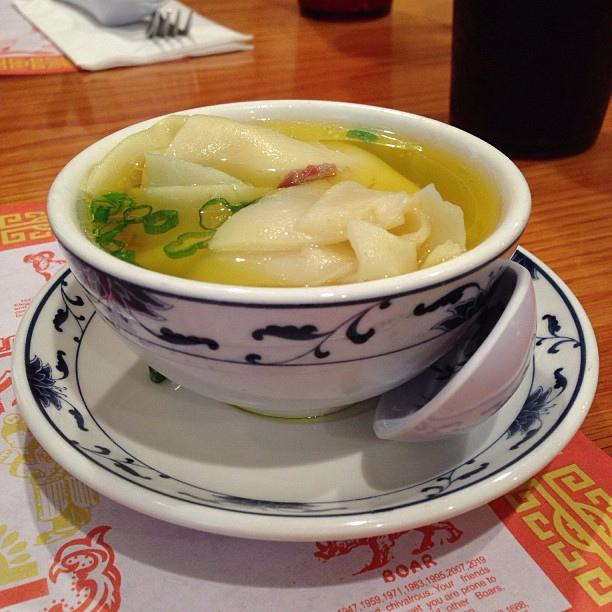What is traditionally eaten as an accompaniment to this dish? Please explain your reasoning. bread. Bread is used to eat with soup. 